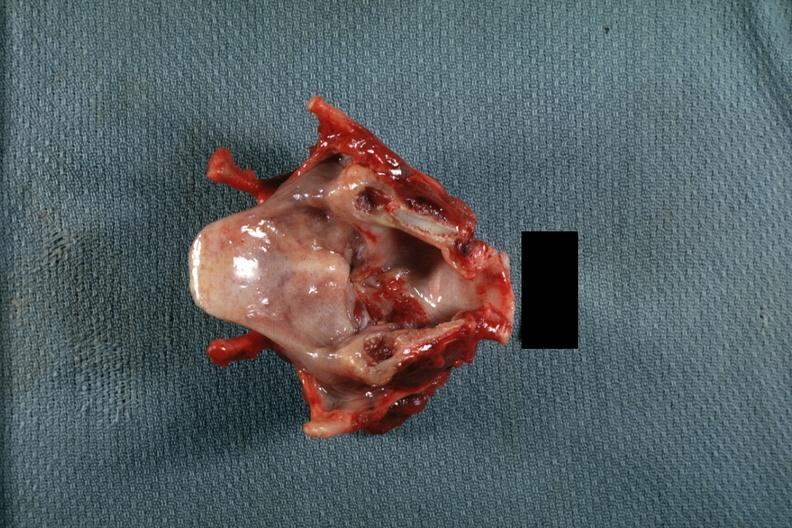what is present?
Answer the question using a single word or phrase. Carcinoma 